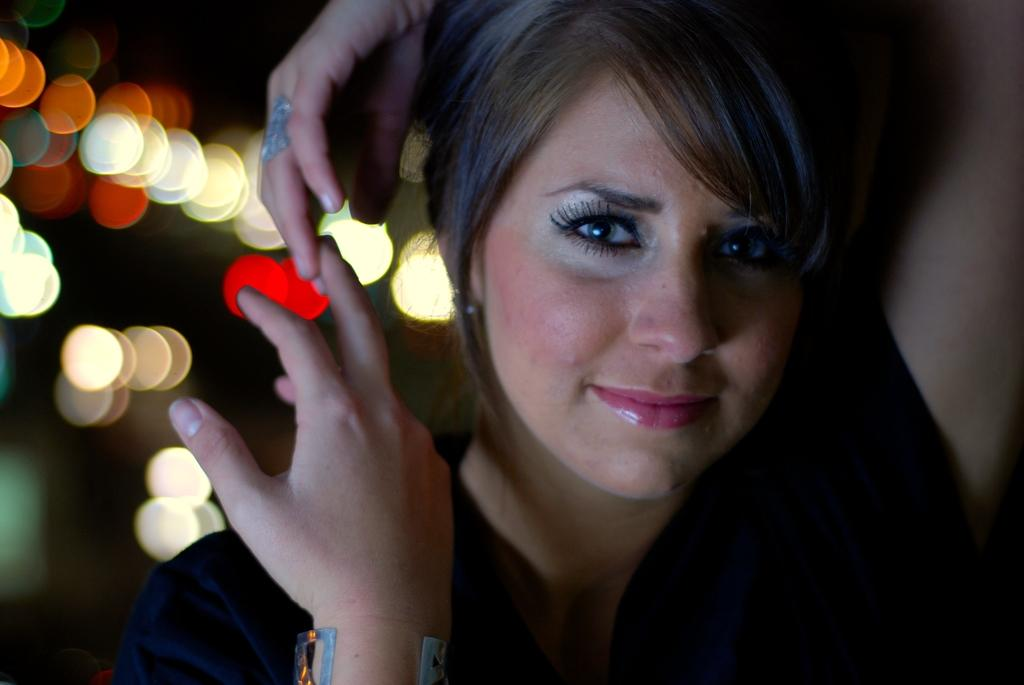What is the main subject of the image? There is a person standing in the image. Can you describe the background of the image? The background appears blurry. What type of achievement is the person celebrating in the image? There is no indication of an achievement or celebration in the image, as it only shows a person standing with a blurry background. 